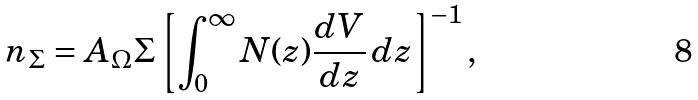Convert formula to latex. <formula><loc_0><loc_0><loc_500><loc_500>n _ { \Sigma } = A _ { \Omega } \Sigma \left [ \int _ { 0 } ^ { \infty } N ( z ) \frac { d V } { d z } \, d z \right ] ^ { - 1 } ,</formula> 